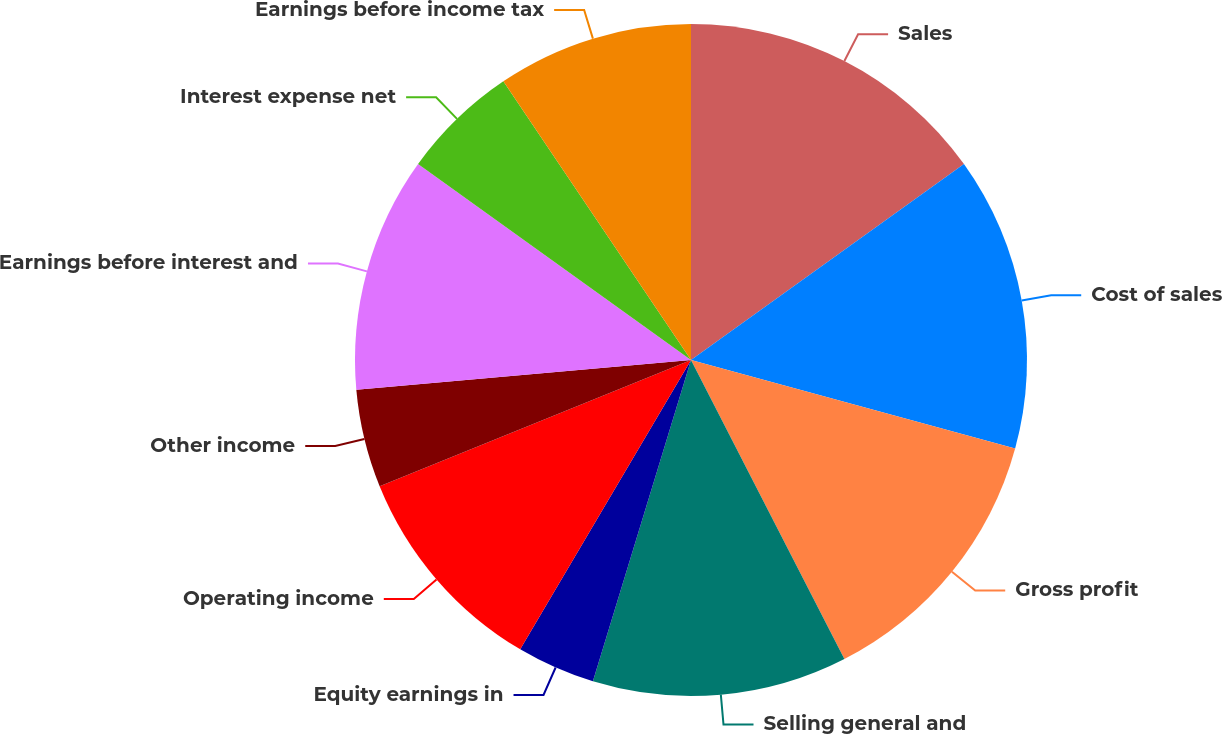<chart> <loc_0><loc_0><loc_500><loc_500><pie_chart><fcel>Sales<fcel>Cost of sales<fcel>Gross profit<fcel>Selling general and<fcel>Equity earnings in<fcel>Operating income<fcel>Other income<fcel>Earnings before interest and<fcel>Interest expense net<fcel>Earnings before income tax<nl><fcel>15.09%<fcel>14.15%<fcel>13.21%<fcel>12.26%<fcel>3.77%<fcel>10.38%<fcel>4.72%<fcel>11.32%<fcel>5.66%<fcel>9.43%<nl></chart> 